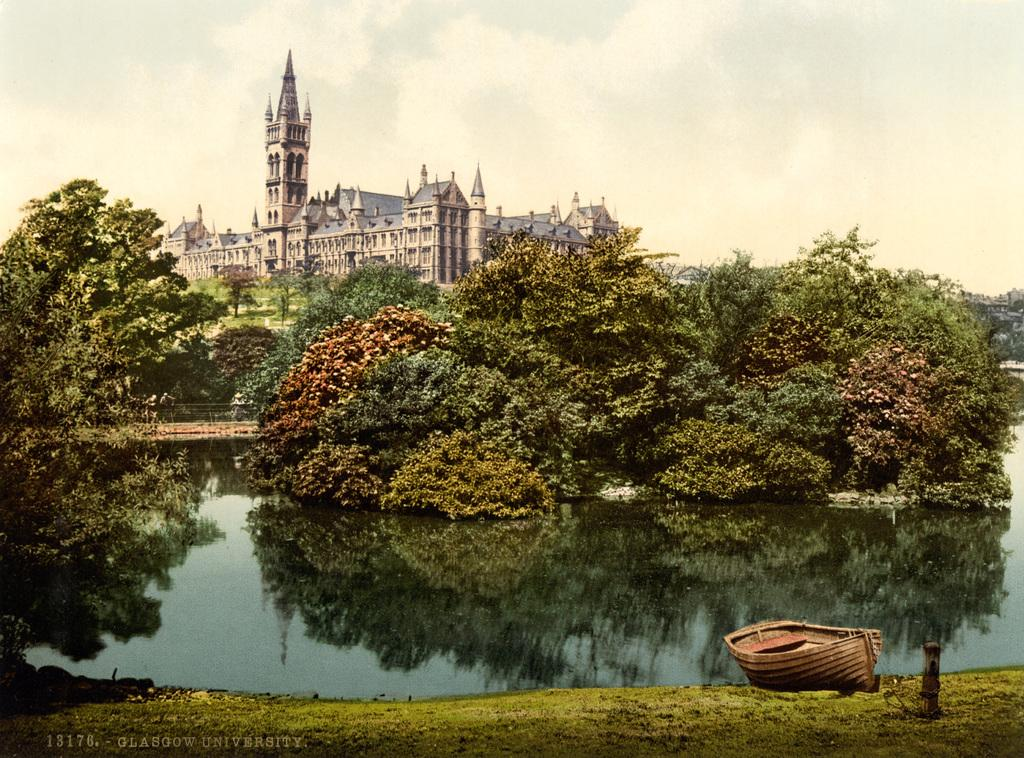What is the main subject of the image? The main subject of the image is a boat. What is the boat situated in? The boat is situated in water. What can be seen in the background of the image? Trees and a building are visible in the background of the image. What feature of the building can be seen in the image? There are windows in the image. What is the color of the sky in the image? The sky is white in color. What book is the monkey reading in the image? There is no monkey or book present in the image. 